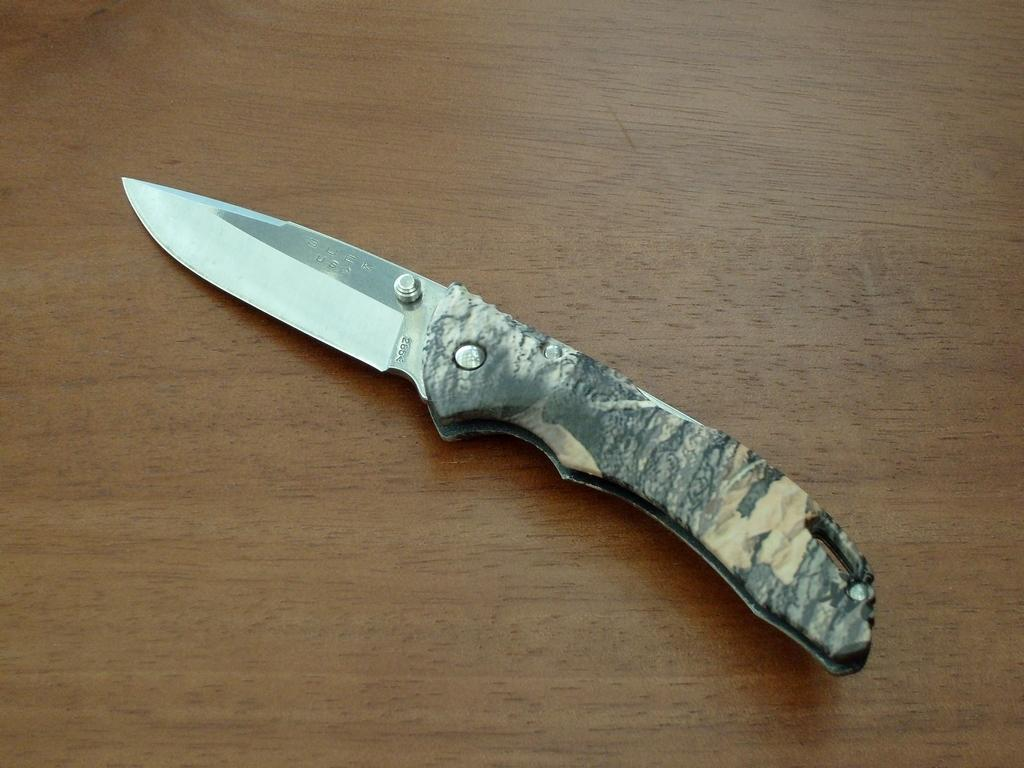What piece of furniture is present in the image? There is a table in the image. What object is placed on the table? There is a knife on the table. How many cubs can be seen playing with the knife in the image? There are no cubs present in the image, and therefore no such activity can be observed. 